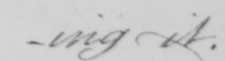What text is written in this handwritten line? -ing it . 